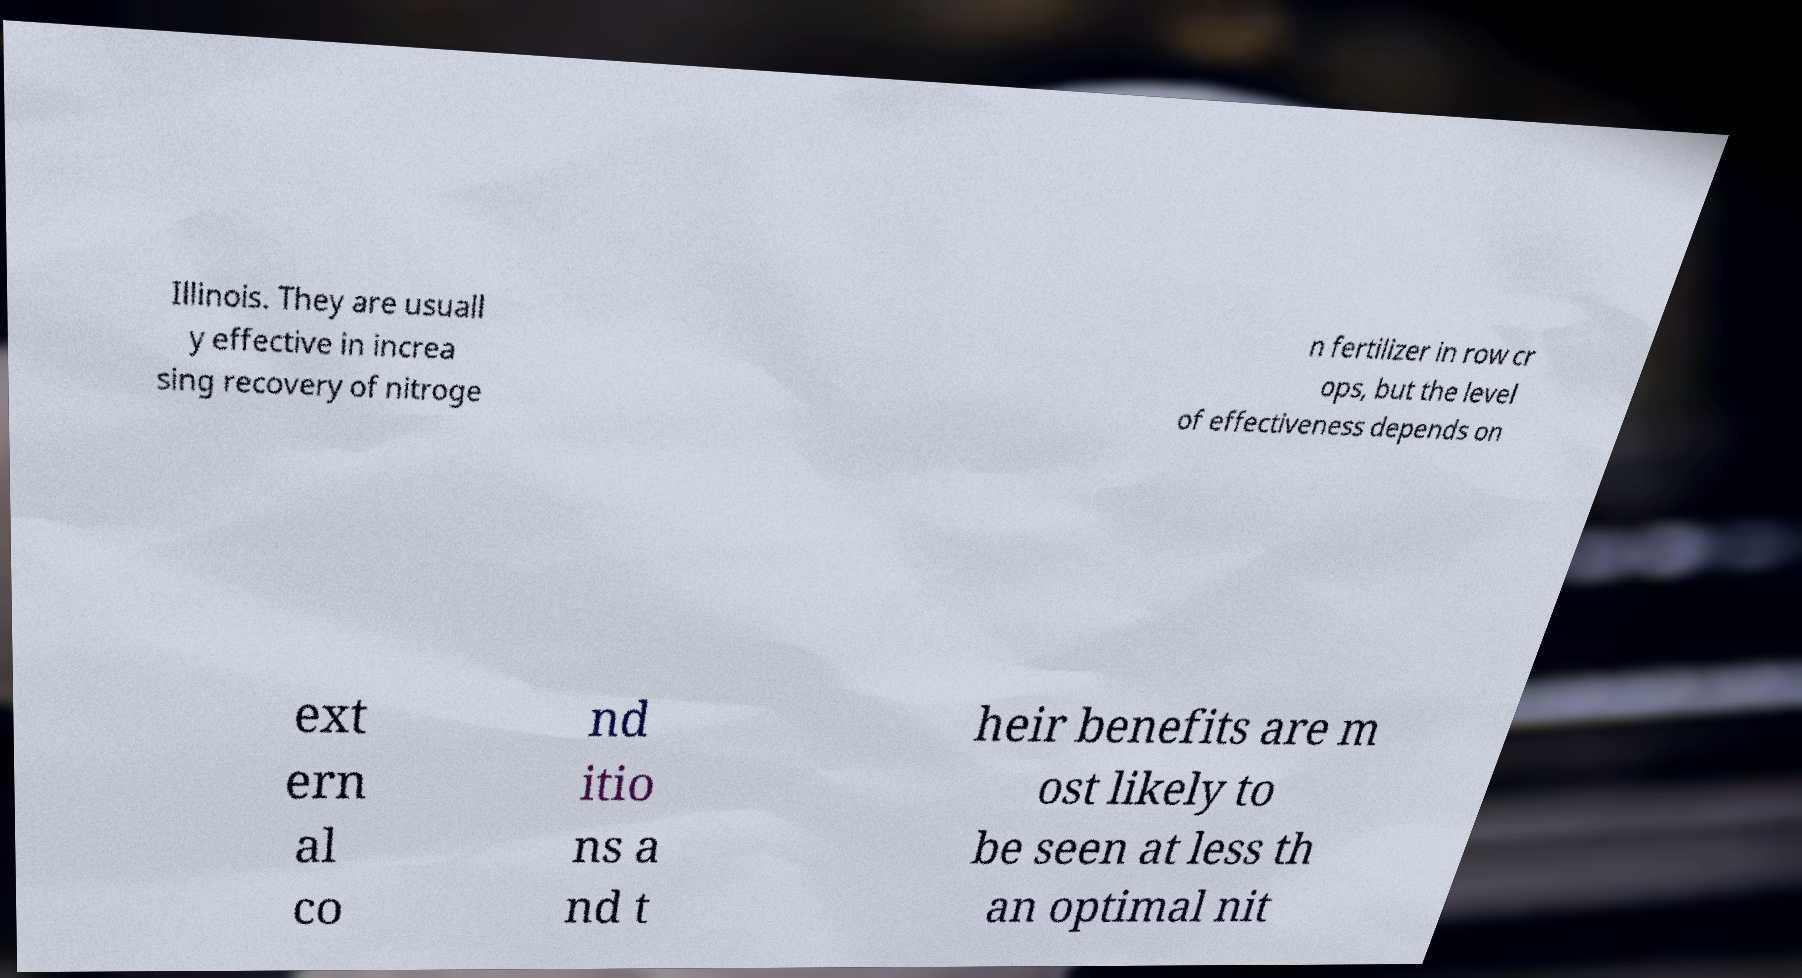There's text embedded in this image that I need extracted. Can you transcribe it verbatim? Illinois. They are usuall y effective in increa sing recovery of nitroge n fertilizer in row cr ops, but the level of effectiveness depends on ext ern al co nd itio ns a nd t heir benefits are m ost likely to be seen at less th an optimal nit 